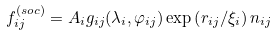<formula> <loc_0><loc_0><loc_500><loc_500>f _ { i j } ^ { ( s o c ) } = A _ { i } g _ { i j } ( \lambda _ { i } , \varphi _ { i j } ) \exp \left ( r _ { i j } / \xi _ { i } \right ) n _ { i j }</formula> 